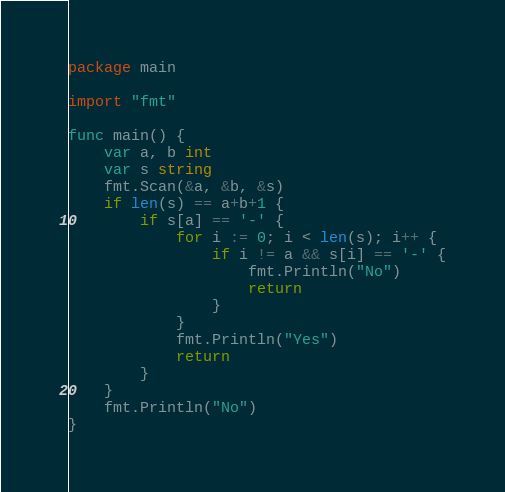<code> <loc_0><loc_0><loc_500><loc_500><_Go_>package main

import "fmt"

func main() {
	var a, b int
	var s string
	fmt.Scan(&a, &b, &s)
	if len(s) == a+b+1 {
		if s[a] == '-' {
			for i := 0; i < len(s); i++ {
				if i != a && s[i] == '-' {
					fmt.Println("No")
					return
				}
			}
			fmt.Println("Yes")
			return
		}
	}
	fmt.Println("No")
}
</code> 